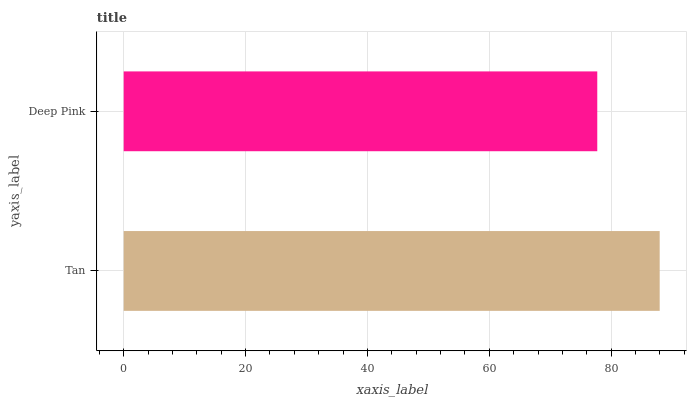Is Deep Pink the minimum?
Answer yes or no. Yes. Is Tan the maximum?
Answer yes or no. Yes. Is Deep Pink the maximum?
Answer yes or no. No. Is Tan greater than Deep Pink?
Answer yes or no. Yes. Is Deep Pink less than Tan?
Answer yes or no. Yes. Is Deep Pink greater than Tan?
Answer yes or no. No. Is Tan less than Deep Pink?
Answer yes or no. No. Is Tan the high median?
Answer yes or no. Yes. Is Deep Pink the low median?
Answer yes or no. Yes. Is Deep Pink the high median?
Answer yes or no. No. Is Tan the low median?
Answer yes or no. No. 